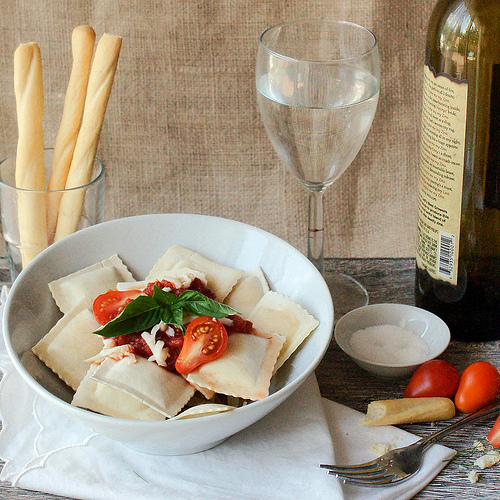<image>
Is there a cup behind the plate? Yes. From this viewpoint, the cup is positioned behind the plate, with the plate partially or fully occluding the cup. Where is the food in relation to the bowl? Is it in the bowl? No. The food is not contained within the bowl. These objects have a different spatial relationship. 